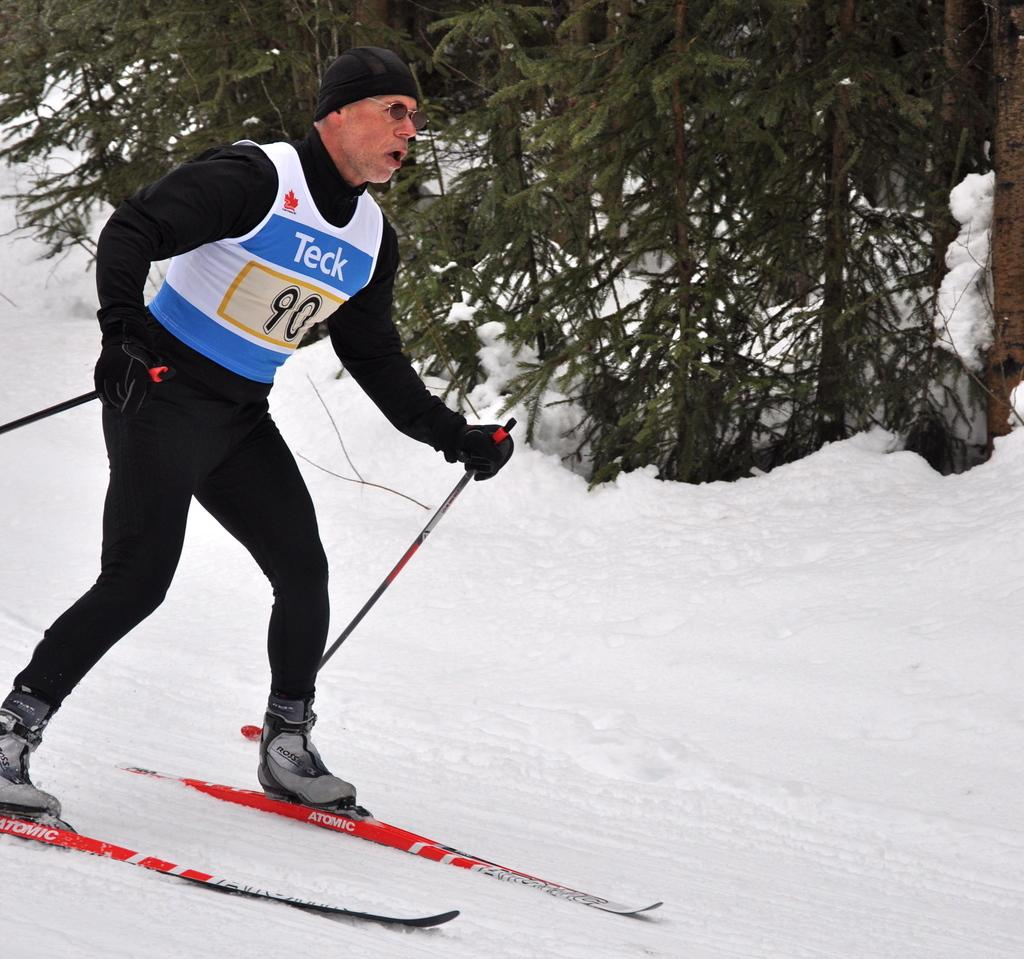What is the man in the image doing? The man is skiing on the snow. What equipment is the man using for skiing? The man is wearing skis and holding sticks, which are likely ski poles. What protective gear is the man wearing? The man is wearing gloves and a cap. What can be seen in the background of the image? There are trees in the background of the image. What type of seafood is being served for treatment during the week in the image? There is no seafood or treatment present in the image; it features a man skiing on the snow. 